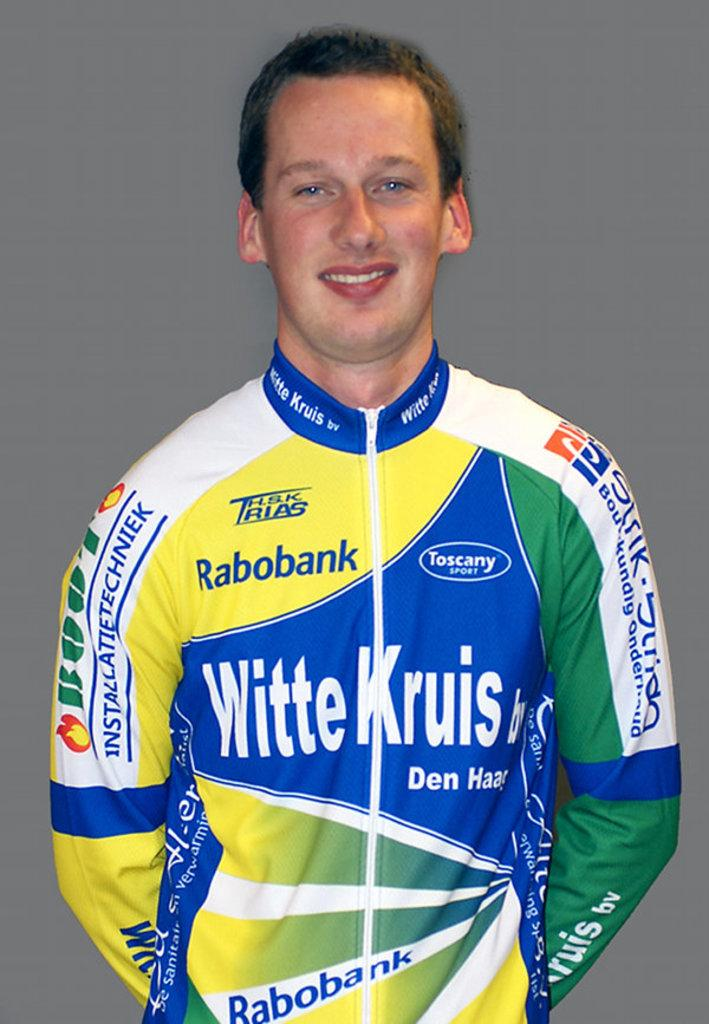<image>
Provide a brief description of the given image. a man with the word witte on his racing outfot 